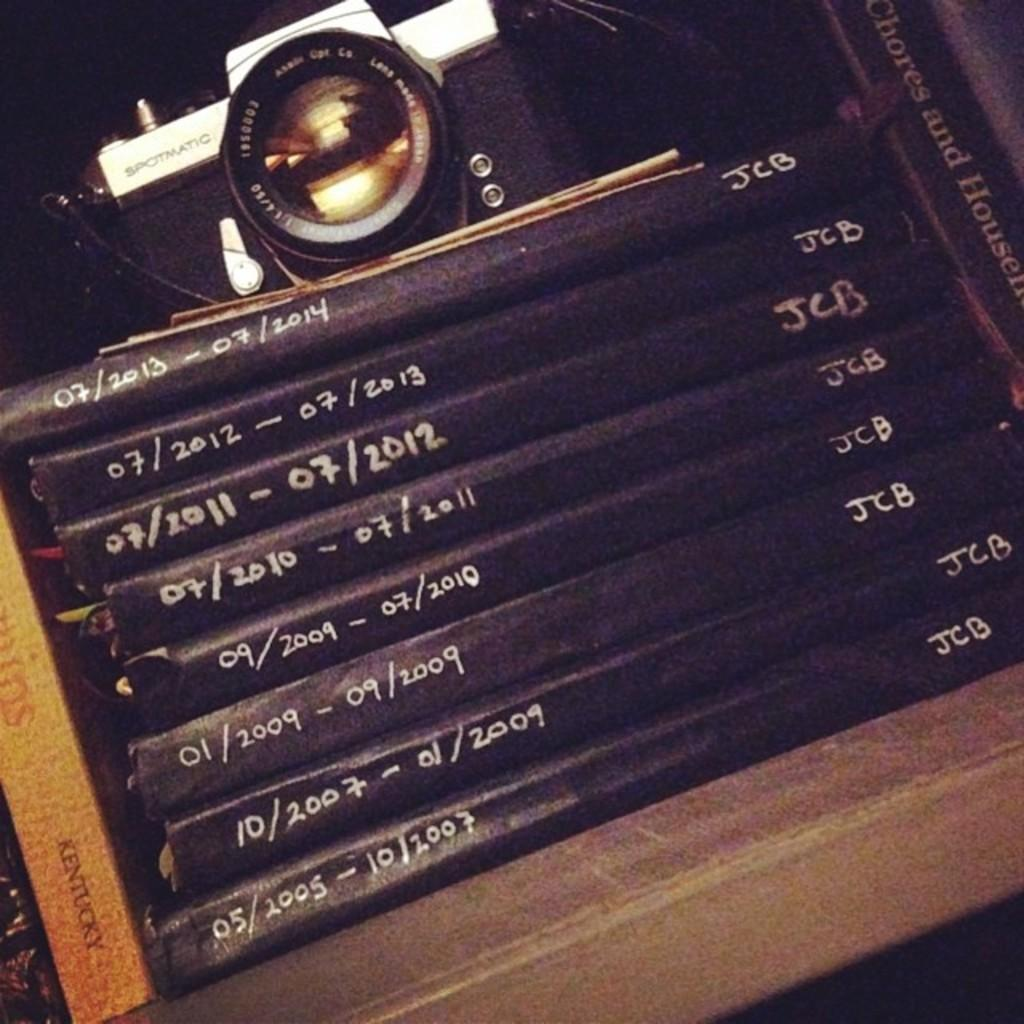<image>
Relay a brief, clear account of the picture shown. a set of books marked with dates 5/2005 to 7/2013, JCB initials. 